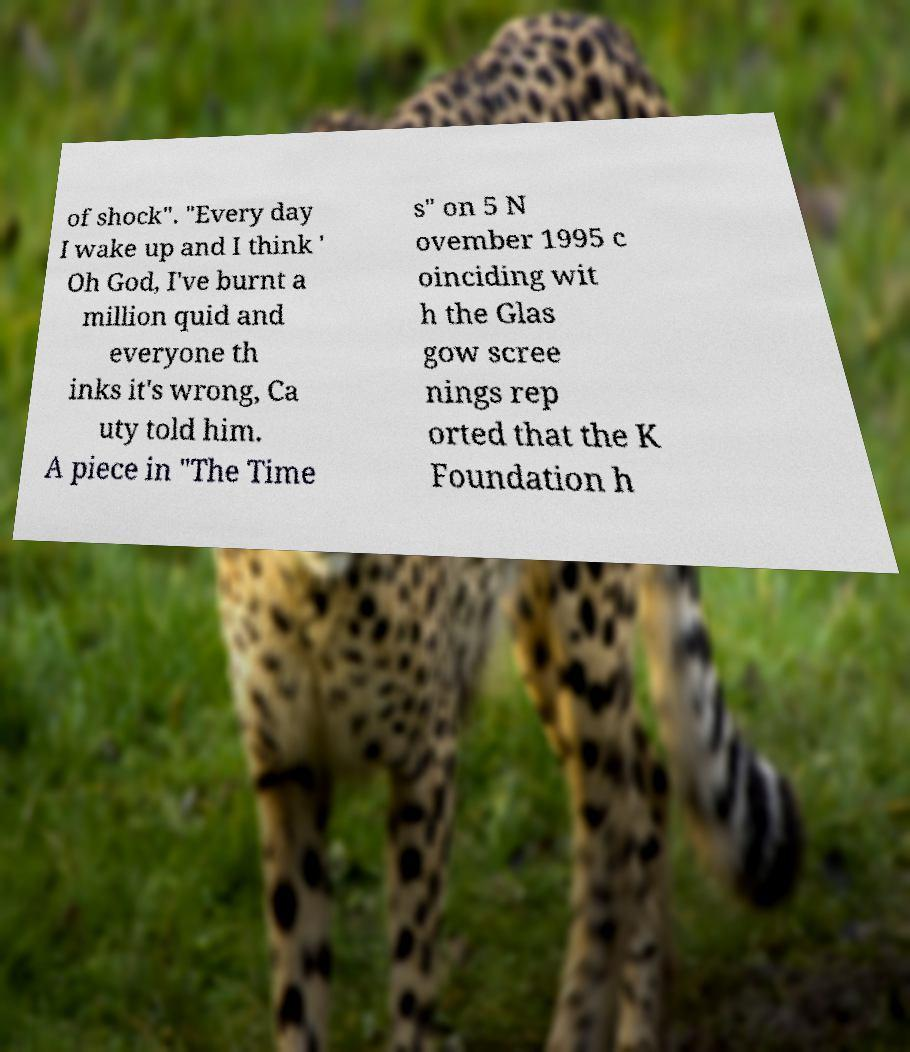Can you read and provide the text displayed in the image?This photo seems to have some interesting text. Can you extract and type it out for me? of shock". "Every day I wake up and I think ' Oh God, I've burnt a million quid and everyone th inks it's wrong, Ca uty told him. A piece in "The Time s" on 5 N ovember 1995 c oinciding wit h the Glas gow scree nings rep orted that the K Foundation h 